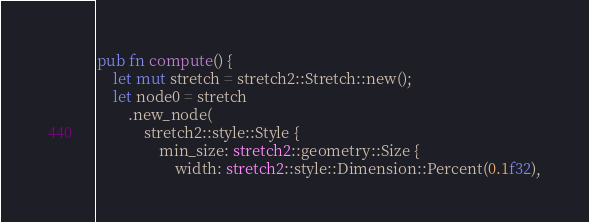Convert code to text. <code><loc_0><loc_0><loc_500><loc_500><_Rust_>pub fn compute() {
    let mut stretch = stretch2::Stretch::new();
    let node0 = stretch
        .new_node(
            stretch2::style::Style {
                min_size: stretch2::geometry::Size {
                    width: stretch2::style::Dimension::Percent(0.1f32),</code> 